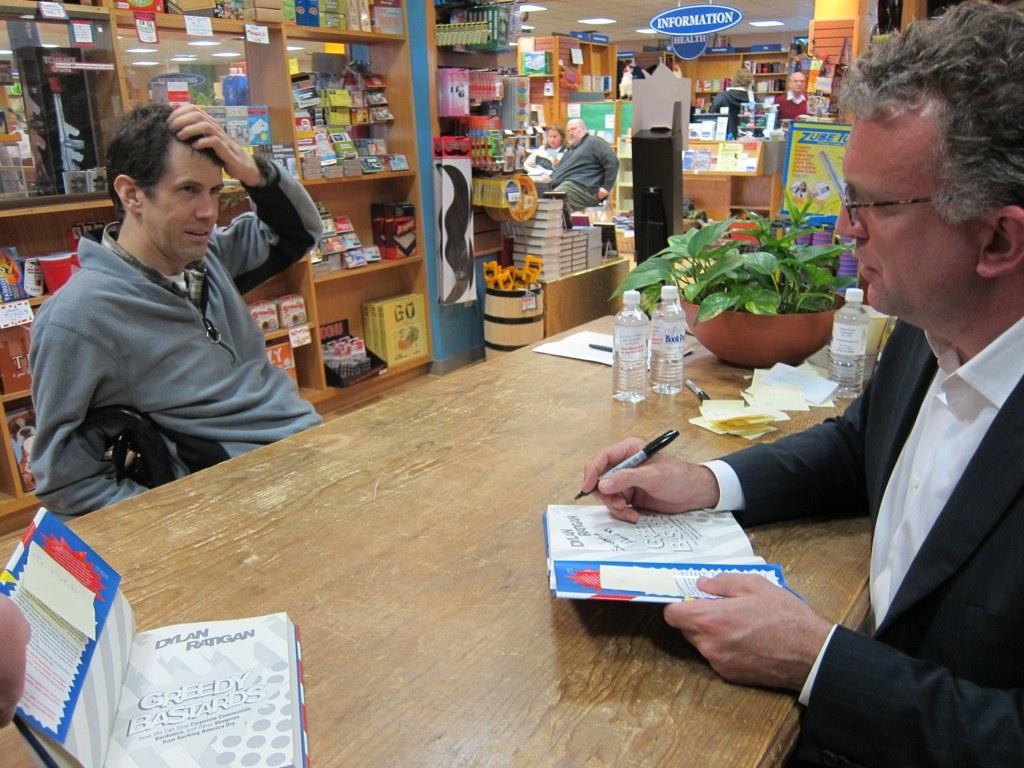Who wrote greedy bastards?
Your response must be concise. Dylan ratigan. What is the title of the book?
Keep it short and to the point. Greedy bastards. 